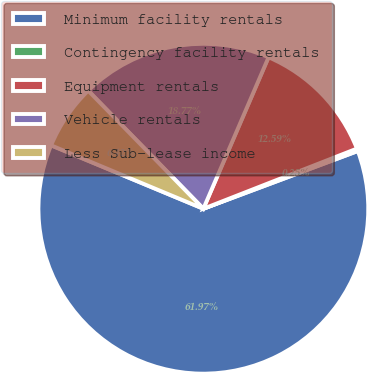<chart> <loc_0><loc_0><loc_500><loc_500><pie_chart><fcel>Minimum facility rentals<fcel>Contingency facility rentals<fcel>Equipment rentals<fcel>Vehicle rentals<fcel>Less Sub-lease income<nl><fcel>61.97%<fcel>0.25%<fcel>12.59%<fcel>18.77%<fcel>6.42%<nl></chart> 